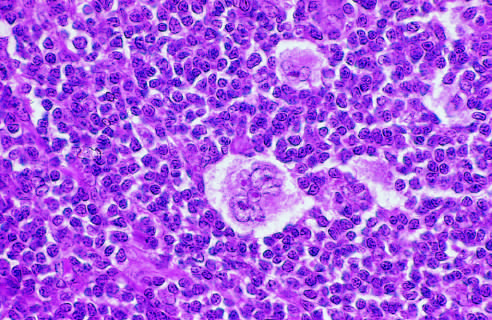what does the multilobed nucleus of the distinctive lacunar cell contain?
Answer the question using a single word or phrase. Many small nucleoli 